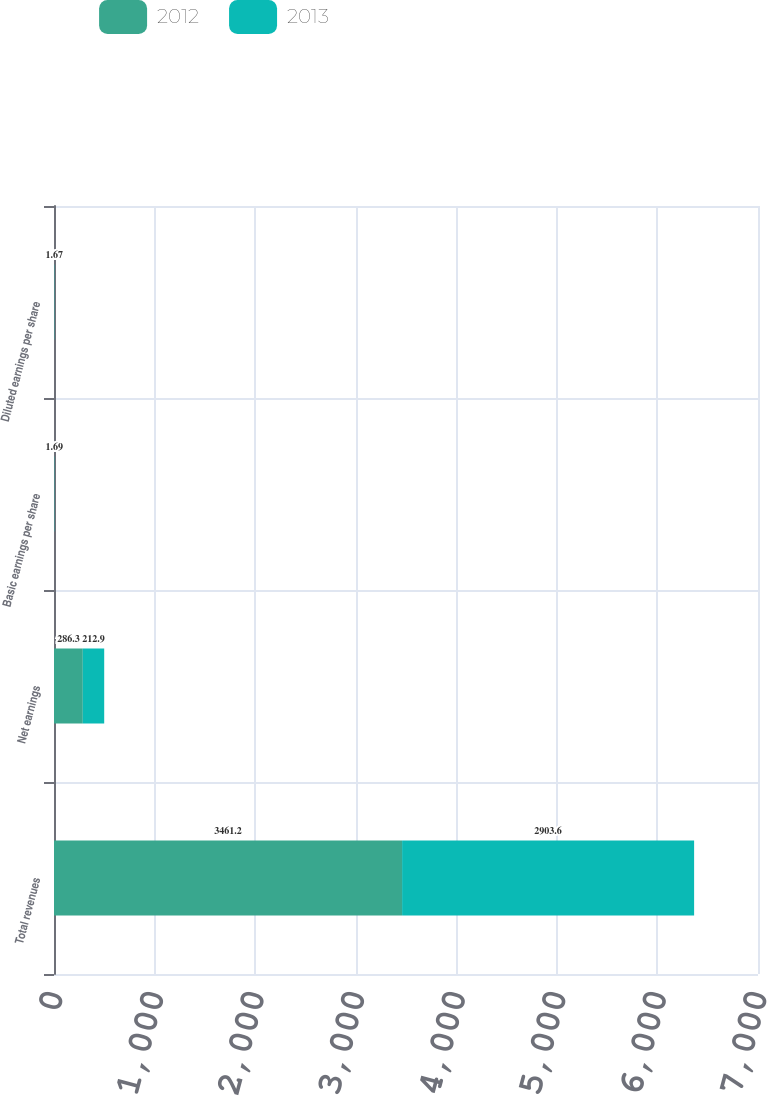Convert chart. <chart><loc_0><loc_0><loc_500><loc_500><stacked_bar_chart><ecel><fcel>Total revenues<fcel>Net earnings<fcel>Basic earnings per share<fcel>Diluted earnings per share<nl><fcel>2012<fcel>3461.2<fcel>286.3<fcel>2.17<fcel>2.14<nl><fcel>2013<fcel>2903.6<fcel>212.9<fcel>1.69<fcel>1.67<nl></chart> 